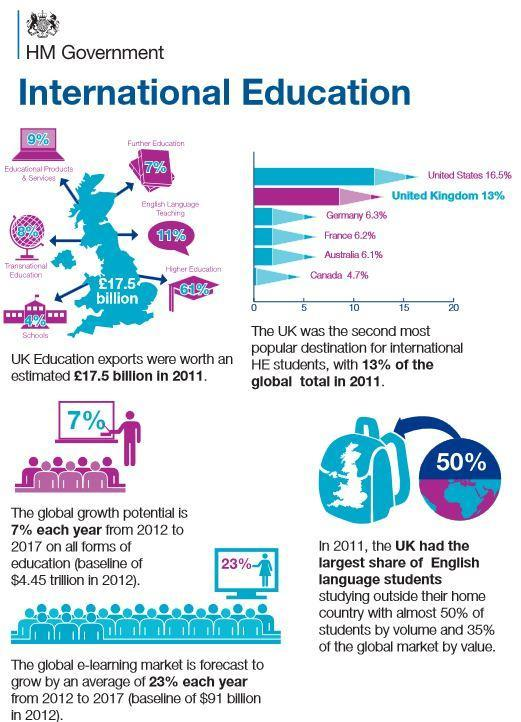What accounts for 61% of UK's education exports?
Answer the question with a short phrase. Higher education Which country is the third most popular destination for international students? Germany 